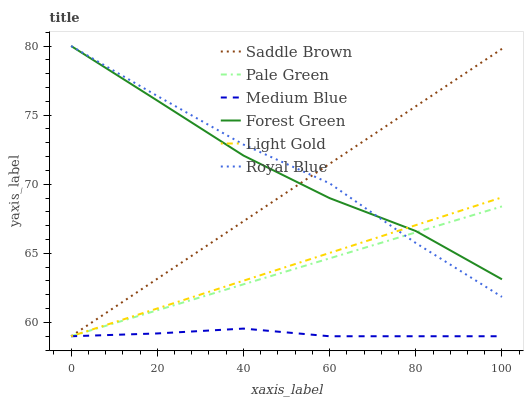Does Medium Blue have the minimum area under the curve?
Answer yes or no. Yes. Does Royal Blue have the maximum area under the curve?
Answer yes or no. Yes. Does Forest Green have the minimum area under the curve?
Answer yes or no. No. Does Forest Green have the maximum area under the curve?
Answer yes or no. No. Is Saddle Brown the smoothest?
Answer yes or no. Yes. Is Royal Blue the roughest?
Answer yes or no. Yes. Is Forest Green the smoothest?
Answer yes or no. No. Is Forest Green the roughest?
Answer yes or no. No. Does Medium Blue have the lowest value?
Answer yes or no. Yes. Does Royal Blue have the lowest value?
Answer yes or no. No. Does Forest Green have the highest value?
Answer yes or no. Yes. Does Pale Green have the highest value?
Answer yes or no. No. Is Medium Blue less than Royal Blue?
Answer yes or no. Yes. Is Forest Green greater than Medium Blue?
Answer yes or no. Yes. Does Royal Blue intersect Forest Green?
Answer yes or no. Yes. Is Royal Blue less than Forest Green?
Answer yes or no. No. Is Royal Blue greater than Forest Green?
Answer yes or no. No. Does Medium Blue intersect Royal Blue?
Answer yes or no. No. 